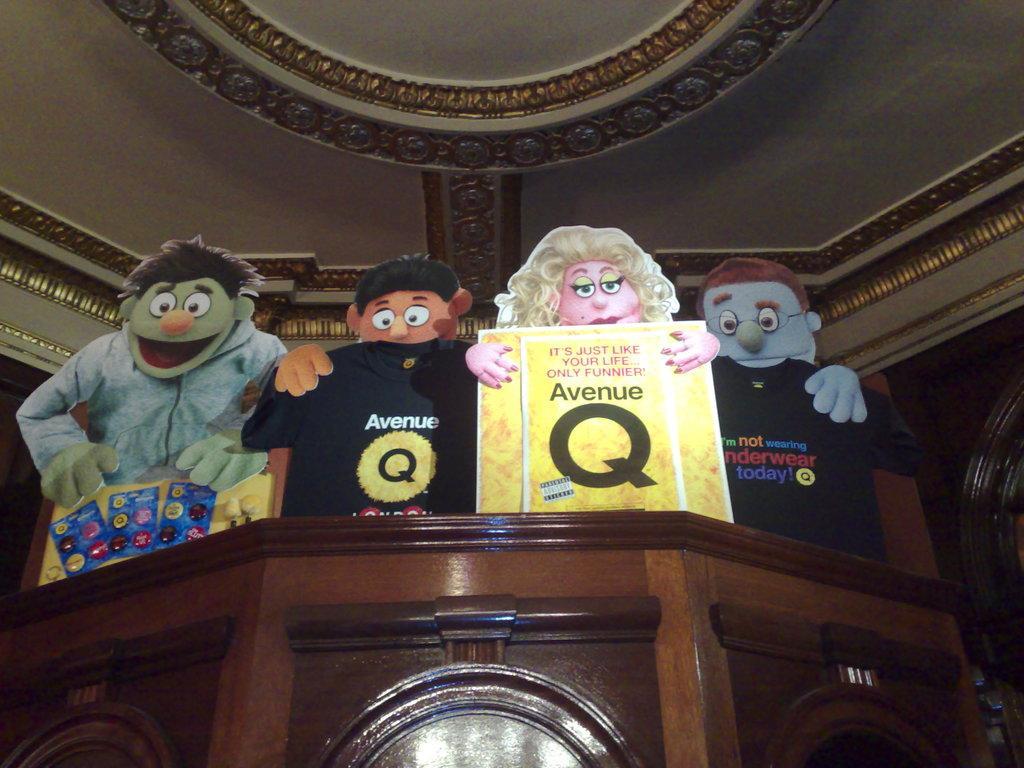Please provide a concise description of this image. In the image there is wooden object, on that there are some cartoon depictions and in the background there is a roof with beautiful carvings. 